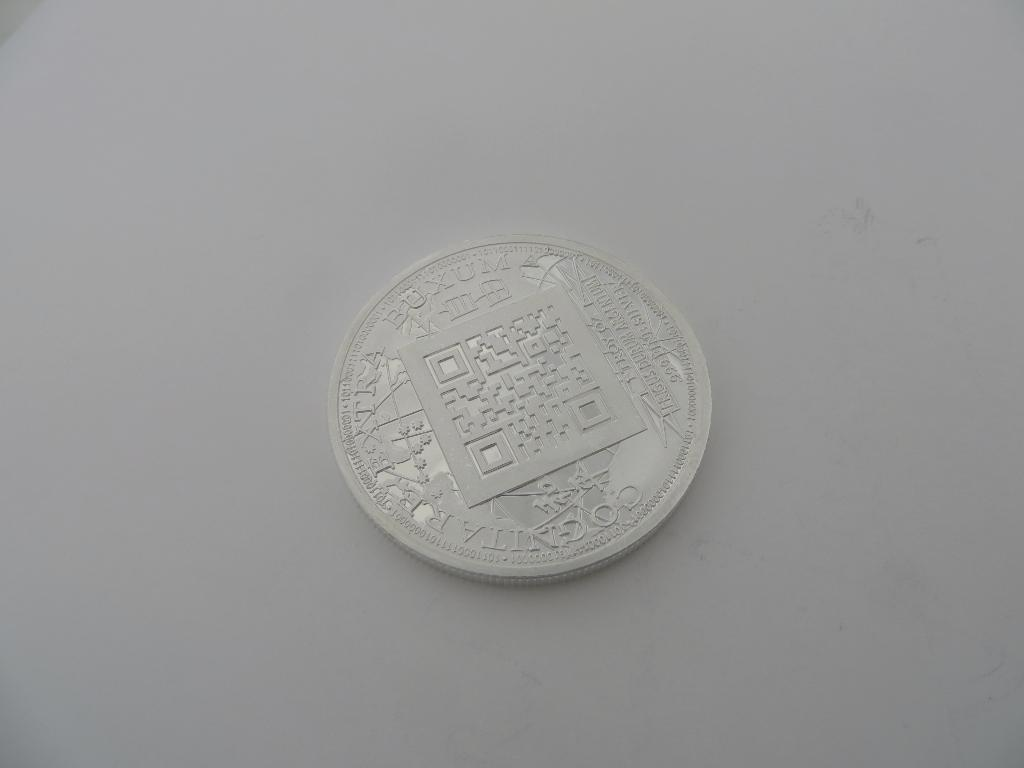<image>
Provide a brief description of the given image. a silver coin with an intricate design has word Buxum on the upper left 